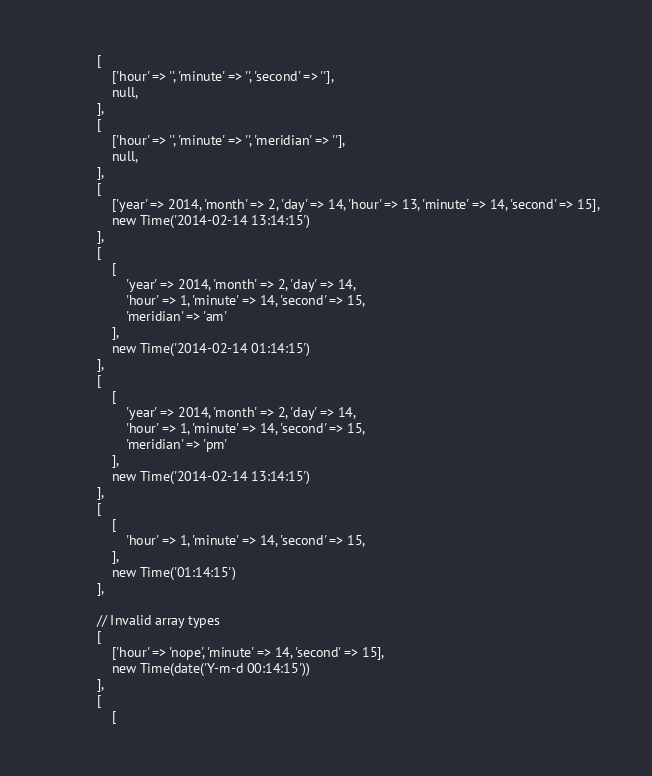Convert code to text. <code><loc_0><loc_0><loc_500><loc_500><_PHP_>            [
                ['hour' => '', 'minute' => '', 'second' => ''],
                null,
            ],
            [
                ['hour' => '', 'minute' => '', 'meridian' => ''],
                null,
            ],
            [
                ['year' => 2014, 'month' => 2, 'day' => 14, 'hour' => 13, 'minute' => 14, 'second' => 15],
                new Time('2014-02-14 13:14:15')
            ],
            [
                [
                    'year' => 2014, 'month' => 2, 'day' => 14,
                    'hour' => 1, 'minute' => 14, 'second' => 15,
                    'meridian' => 'am'
                ],
                new Time('2014-02-14 01:14:15')
            ],
            [
                [
                    'year' => 2014, 'month' => 2, 'day' => 14,
                    'hour' => 1, 'minute' => 14, 'second' => 15,
                    'meridian' => 'pm'
                ],
                new Time('2014-02-14 13:14:15')
            ],
            [
                [
                    'hour' => 1, 'minute' => 14, 'second' => 15,
                ],
                new Time('01:14:15')
            ],

            // Invalid array types
            [
                ['hour' => 'nope', 'minute' => 14, 'second' => 15],
                new Time(date('Y-m-d 00:14:15'))
            ],
            [
                [</code> 